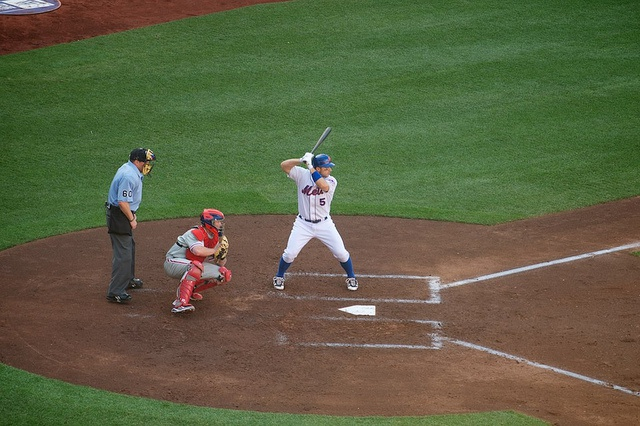Describe the objects in this image and their specific colors. I can see people in gray, lavender, and darkgray tones, people in gray, darkgray, brown, and maroon tones, people in gray, black, and lightblue tones, baseball glove in gray, tan, and black tones, and baseball bat in gray, darkgray, and darkgreen tones in this image. 